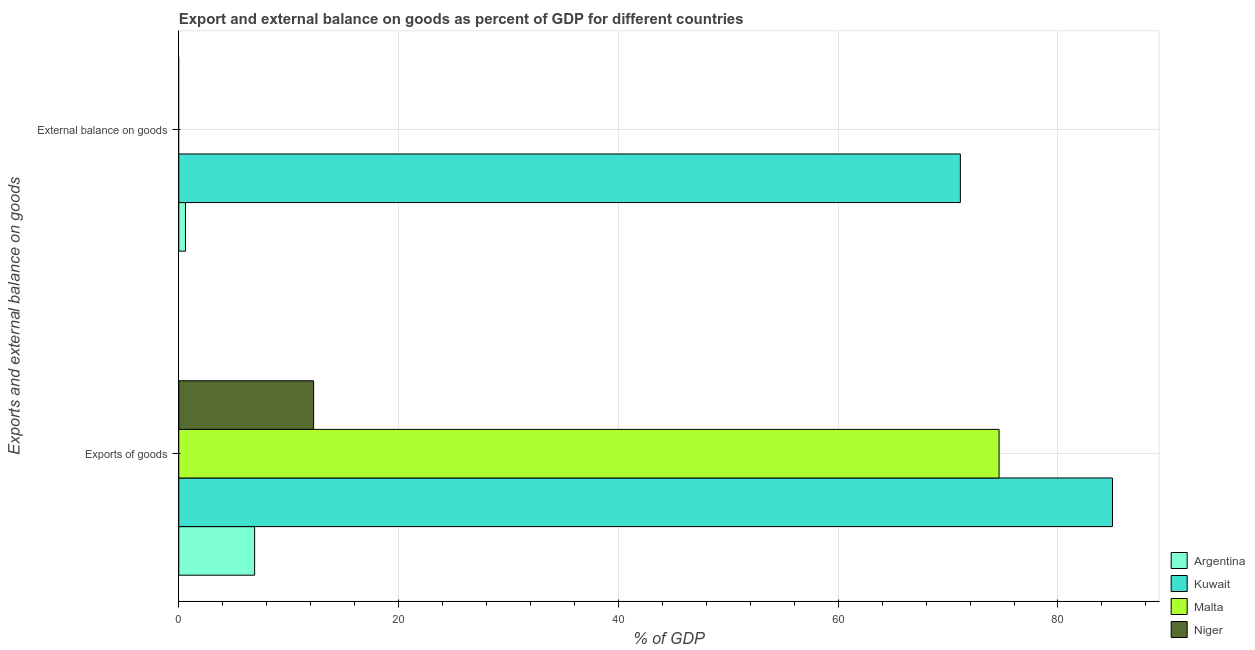How many groups of bars are there?
Offer a very short reply. 2. Are the number of bars on each tick of the Y-axis equal?
Give a very brief answer. No. How many bars are there on the 1st tick from the bottom?
Give a very brief answer. 4. What is the label of the 1st group of bars from the top?
Your response must be concise. External balance on goods. What is the export of goods as percentage of gdp in Kuwait?
Provide a succinct answer. 84.96. Across all countries, what is the maximum export of goods as percentage of gdp?
Provide a succinct answer. 84.96. In which country was the external balance on goods as percentage of gdp maximum?
Your response must be concise. Kuwait. What is the total export of goods as percentage of gdp in the graph?
Offer a terse response. 178.77. What is the difference between the export of goods as percentage of gdp in Argentina and that in Malta?
Offer a very short reply. -67.74. What is the difference between the external balance on goods as percentage of gdp in Malta and the export of goods as percentage of gdp in Kuwait?
Give a very brief answer. -84.96. What is the average external balance on goods as percentage of gdp per country?
Your response must be concise. 17.93. What is the difference between the external balance on goods as percentage of gdp and export of goods as percentage of gdp in Kuwait?
Give a very brief answer. -13.84. In how many countries, is the external balance on goods as percentage of gdp greater than 60 %?
Give a very brief answer. 1. What is the ratio of the export of goods as percentage of gdp in Malta to that in Niger?
Your answer should be compact. 6.08. Is the export of goods as percentage of gdp in Kuwait less than that in Niger?
Your answer should be very brief. No. In how many countries, is the export of goods as percentage of gdp greater than the average export of goods as percentage of gdp taken over all countries?
Offer a terse response. 2. What is the difference between two consecutive major ticks on the X-axis?
Give a very brief answer. 20. Are the values on the major ticks of X-axis written in scientific E-notation?
Your answer should be compact. No. How many legend labels are there?
Offer a terse response. 4. How are the legend labels stacked?
Offer a terse response. Vertical. What is the title of the graph?
Make the answer very short. Export and external balance on goods as percent of GDP for different countries. What is the label or title of the X-axis?
Your response must be concise. % of GDP. What is the label or title of the Y-axis?
Your answer should be very brief. Exports and external balance on goods. What is the % of GDP of Argentina in Exports of goods?
Provide a short and direct response. 6.9. What is the % of GDP of Kuwait in Exports of goods?
Provide a succinct answer. 84.96. What is the % of GDP of Malta in Exports of goods?
Offer a very short reply. 74.64. What is the % of GDP in Niger in Exports of goods?
Provide a short and direct response. 12.27. What is the % of GDP in Argentina in External balance on goods?
Provide a short and direct response. 0.61. What is the % of GDP in Kuwait in External balance on goods?
Your answer should be compact. 71.12. What is the % of GDP of Malta in External balance on goods?
Your answer should be very brief. 0. Across all Exports and external balance on goods, what is the maximum % of GDP of Argentina?
Provide a short and direct response. 6.9. Across all Exports and external balance on goods, what is the maximum % of GDP in Kuwait?
Make the answer very short. 84.96. Across all Exports and external balance on goods, what is the maximum % of GDP of Malta?
Your answer should be very brief. 74.64. Across all Exports and external balance on goods, what is the maximum % of GDP in Niger?
Provide a succinct answer. 12.27. Across all Exports and external balance on goods, what is the minimum % of GDP in Argentina?
Make the answer very short. 0.61. Across all Exports and external balance on goods, what is the minimum % of GDP of Kuwait?
Offer a very short reply. 71.12. Across all Exports and external balance on goods, what is the minimum % of GDP of Malta?
Offer a terse response. 0. What is the total % of GDP of Argentina in the graph?
Your answer should be very brief. 7.52. What is the total % of GDP of Kuwait in the graph?
Provide a succinct answer. 156.08. What is the total % of GDP of Malta in the graph?
Give a very brief answer. 74.64. What is the total % of GDP in Niger in the graph?
Offer a very short reply. 12.27. What is the difference between the % of GDP of Argentina in Exports of goods and that in External balance on goods?
Provide a succinct answer. 6.29. What is the difference between the % of GDP of Kuwait in Exports of goods and that in External balance on goods?
Your answer should be very brief. 13.84. What is the difference between the % of GDP of Argentina in Exports of goods and the % of GDP of Kuwait in External balance on goods?
Provide a short and direct response. -64.21. What is the average % of GDP in Argentina per Exports and external balance on goods?
Give a very brief answer. 3.76. What is the average % of GDP of Kuwait per Exports and external balance on goods?
Your answer should be compact. 78.04. What is the average % of GDP of Malta per Exports and external balance on goods?
Your response must be concise. 37.32. What is the average % of GDP in Niger per Exports and external balance on goods?
Offer a terse response. 6.14. What is the difference between the % of GDP in Argentina and % of GDP in Kuwait in Exports of goods?
Give a very brief answer. -78.06. What is the difference between the % of GDP in Argentina and % of GDP in Malta in Exports of goods?
Ensure brevity in your answer.  -67.74. What is the difference between the % of GDP in Argentina and % of GDP in Niger in Exports of goods?
Your response must be concise. -5.37. What is the difference between the % of GDP of Kuwait and % of GDP of Malta in Exports of goods?
Provide a short and direct response. 10.32. What is the difference between the % of GDP of Kuwait and % of GDP of Niger in Exports of goods?
Your answer should be compact. 72.69. What is the difference between the % of GDP in Malta and % of GDP in Niger in Exports of goods?
Keep it short and to the point. 62.37. What is the difference between the % of GDP in Argentina and % of GDP in Kuwait in External balance on goods?
Your answer should be compact. -70.5. What is the ratio of the % of GDP of Argentina in Exports of goods to that in External balance on goods?
Offer a very short reply. 11.25. What is the ratio of the % of GDP of Kuwait in Exports of goods to that in External balance on goods?
Keep it short and to the point. 1.19. What is the difference between the highest and the second highest % of GDP of Argentina?
Make the answer very short. 6.29. What is the difference between the highest and the second highest % of GDP in Kuwait?
Offer a terse response. 13.84. What is the difference between the highest and the lowest % of GDP in Argentina?
Ensure brevity in your answer.  6.29. What is the difference between the highest and the lowest % of GDP of Kuwait?
Give a very brief answer. 13.84. What is the difference between the highest and the lowest % of GDP of Malta?
Your response must be concise. 74.64. What is the difference between the highest and the lowest % of GDP of Niger?
Your answer should be compact. 12.27. 